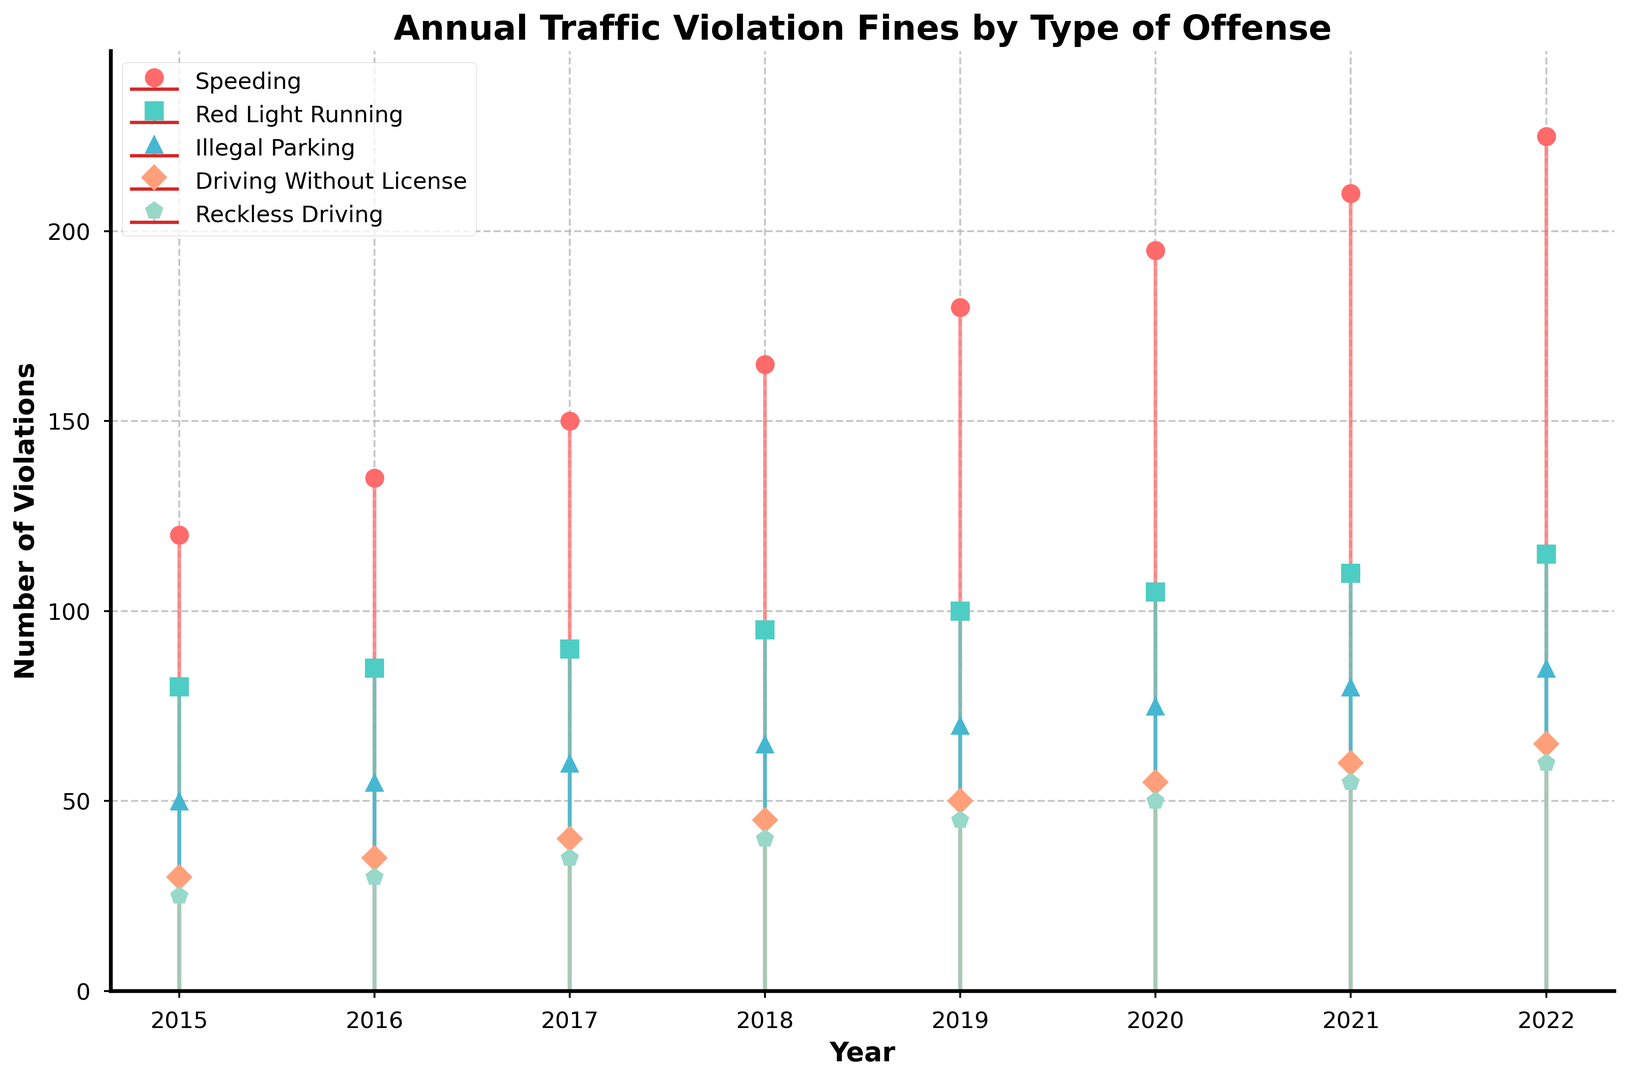Which type of traffic violation had the highest number of fines in 2022? To determine the highest number of fines in 2022, look at the data points for all types of traffic violations for that year and identify the maximum. The highest value is 225 for Speeding.
Answer: Speeding Has the number of fines for "Driving Without License" increased or decreased between 2015 and 2022? Compare the number of fines for "Driving Without License" in the years 2015 and 2022. In 2015, there were 30 fines and in 2022, there were 65 fines, showing an increase.
Answer: Increased Which year saw the largest increase in fines for "Illegal Parking" compared to the previous year? Calculate the difference in fines for "Illegal Parking" between consecutive years and identify the largest change. The largest increase is from 2018 to 2019 (70-65=5).
Answer: Between 2018 and 2019 What is the total number of fines for "Reckless Driving" from 2015 to 2022? Sum the fines for "Reckless Driving" over all years from 2015 to 2022: 25 + 30 + 35 + 40 + 45 + 50 + 55 + 60 = 340.
Answer: 340 Which type of violation showed the least annual increase on average between 2015 and 2022? To find the type of violation with the least average annual increase, calculate the average annual increase for each type: Speeding: 15, Red Light Running: 5, Illegal Parking: 5, Driving Without License: 5, Reckless Driving: 5. "Red Light Running", "Illegal Parking", "Driving Without License", "Reckless Driving" all have the same least increase (5).
Answer: Red Light Running, Illegal Parking, Driving Without License, Reckless Driving How does the number of fines for "Reckless Driving" in 2021 compare to those for "Speeding" in 2017? Compare the number of fines for "Reckless Driving" in 2021 with "Speeding" in 2017. In 2021, "Reckless Driving" has 55 fines, while "Speeding" in 2017 has 150 fines. 150 is greater than 55.
Answer: Less What is the average number of fines for "Red Light Running" over the entire period from 2015 to 2022? Calculate the total number of fines for "Red Light Running" and divide by the number of years: (80+85+90+95+100+105+110+115)/8 = 96.25.
Answer: 96.25 